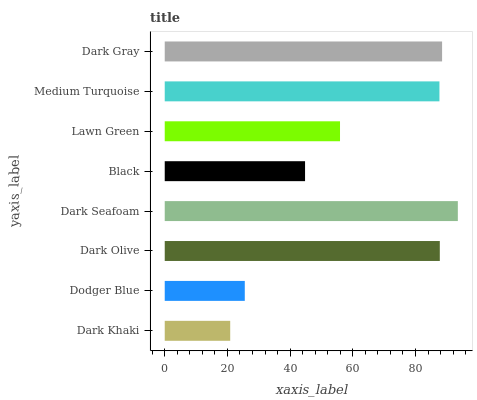Is Dark Khaki the minimum?
Answer yes or no. Yes. Is Dark Seafoam the maximum?
Answer yes or no. Yes. Is Dodger Blue the minimum?
Answer yes or no. No. Is Dodger Blue the maximum?
Answer yes or no. No. Is Dodger Blue greater than Dark Khaki?
Answer yes or no. Yes. Is Dark Khaki less than Dodger Blue?
Answer yes or no. Yes. Is Dark Khaki greater than Dodger Blue?
Answer yes or no. No. Is Dodger Blue less than Dark Khaki?
Answer yes or no. No. Is Medium Turquoise the high median?
Answer yes or no. Yes. Is Lawn Green the low median?
Answer yes or no. Yes. Is Lawn Green the high median?
Answer yes or no. No. Is Dodger Blue the low median?
Answer yes or no. No. 